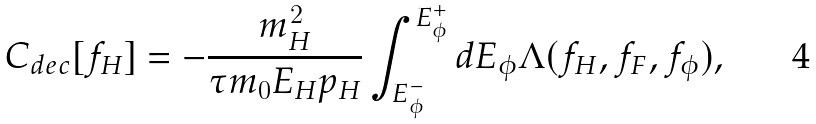<formula> <loc_0><loc_0><loc_500><loc_500>C _ { d e c } [ f _ { H } ] = - \frac { m _ { H } ^ { 2 } } { \tau m _ { 0 } E _ { H } p _ { H } } \int _ { E _ { \phi } ^ { - } } ^ { { E _ { \phi } ^ { + } } } d E _ { \phi } \Lambda ( f _ { H } , f _ { F } , f _ { \phi } ) ,</formula> 